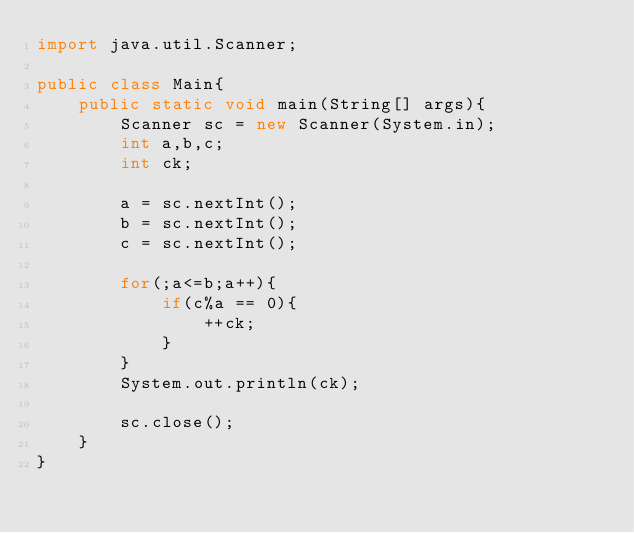<code> <loc_0><loc_0><loc_500><loc_500><_Java_>import java.util.Scanner;

public class Main{
    public static void main(String[] args){
        Scanner sc = new Scanner(System.in);
        int a,b,c;
        int ck;
        
        a = sc.nextInt();
        b = sc.nextInt();
        c = sc.nextInt();
        
        for(;a<=b;a++){
            if(c%a == 0){
                ++ck;
            }
        }
        System.out.println(ck);
        
        sc.close();
    }
}
</code> 